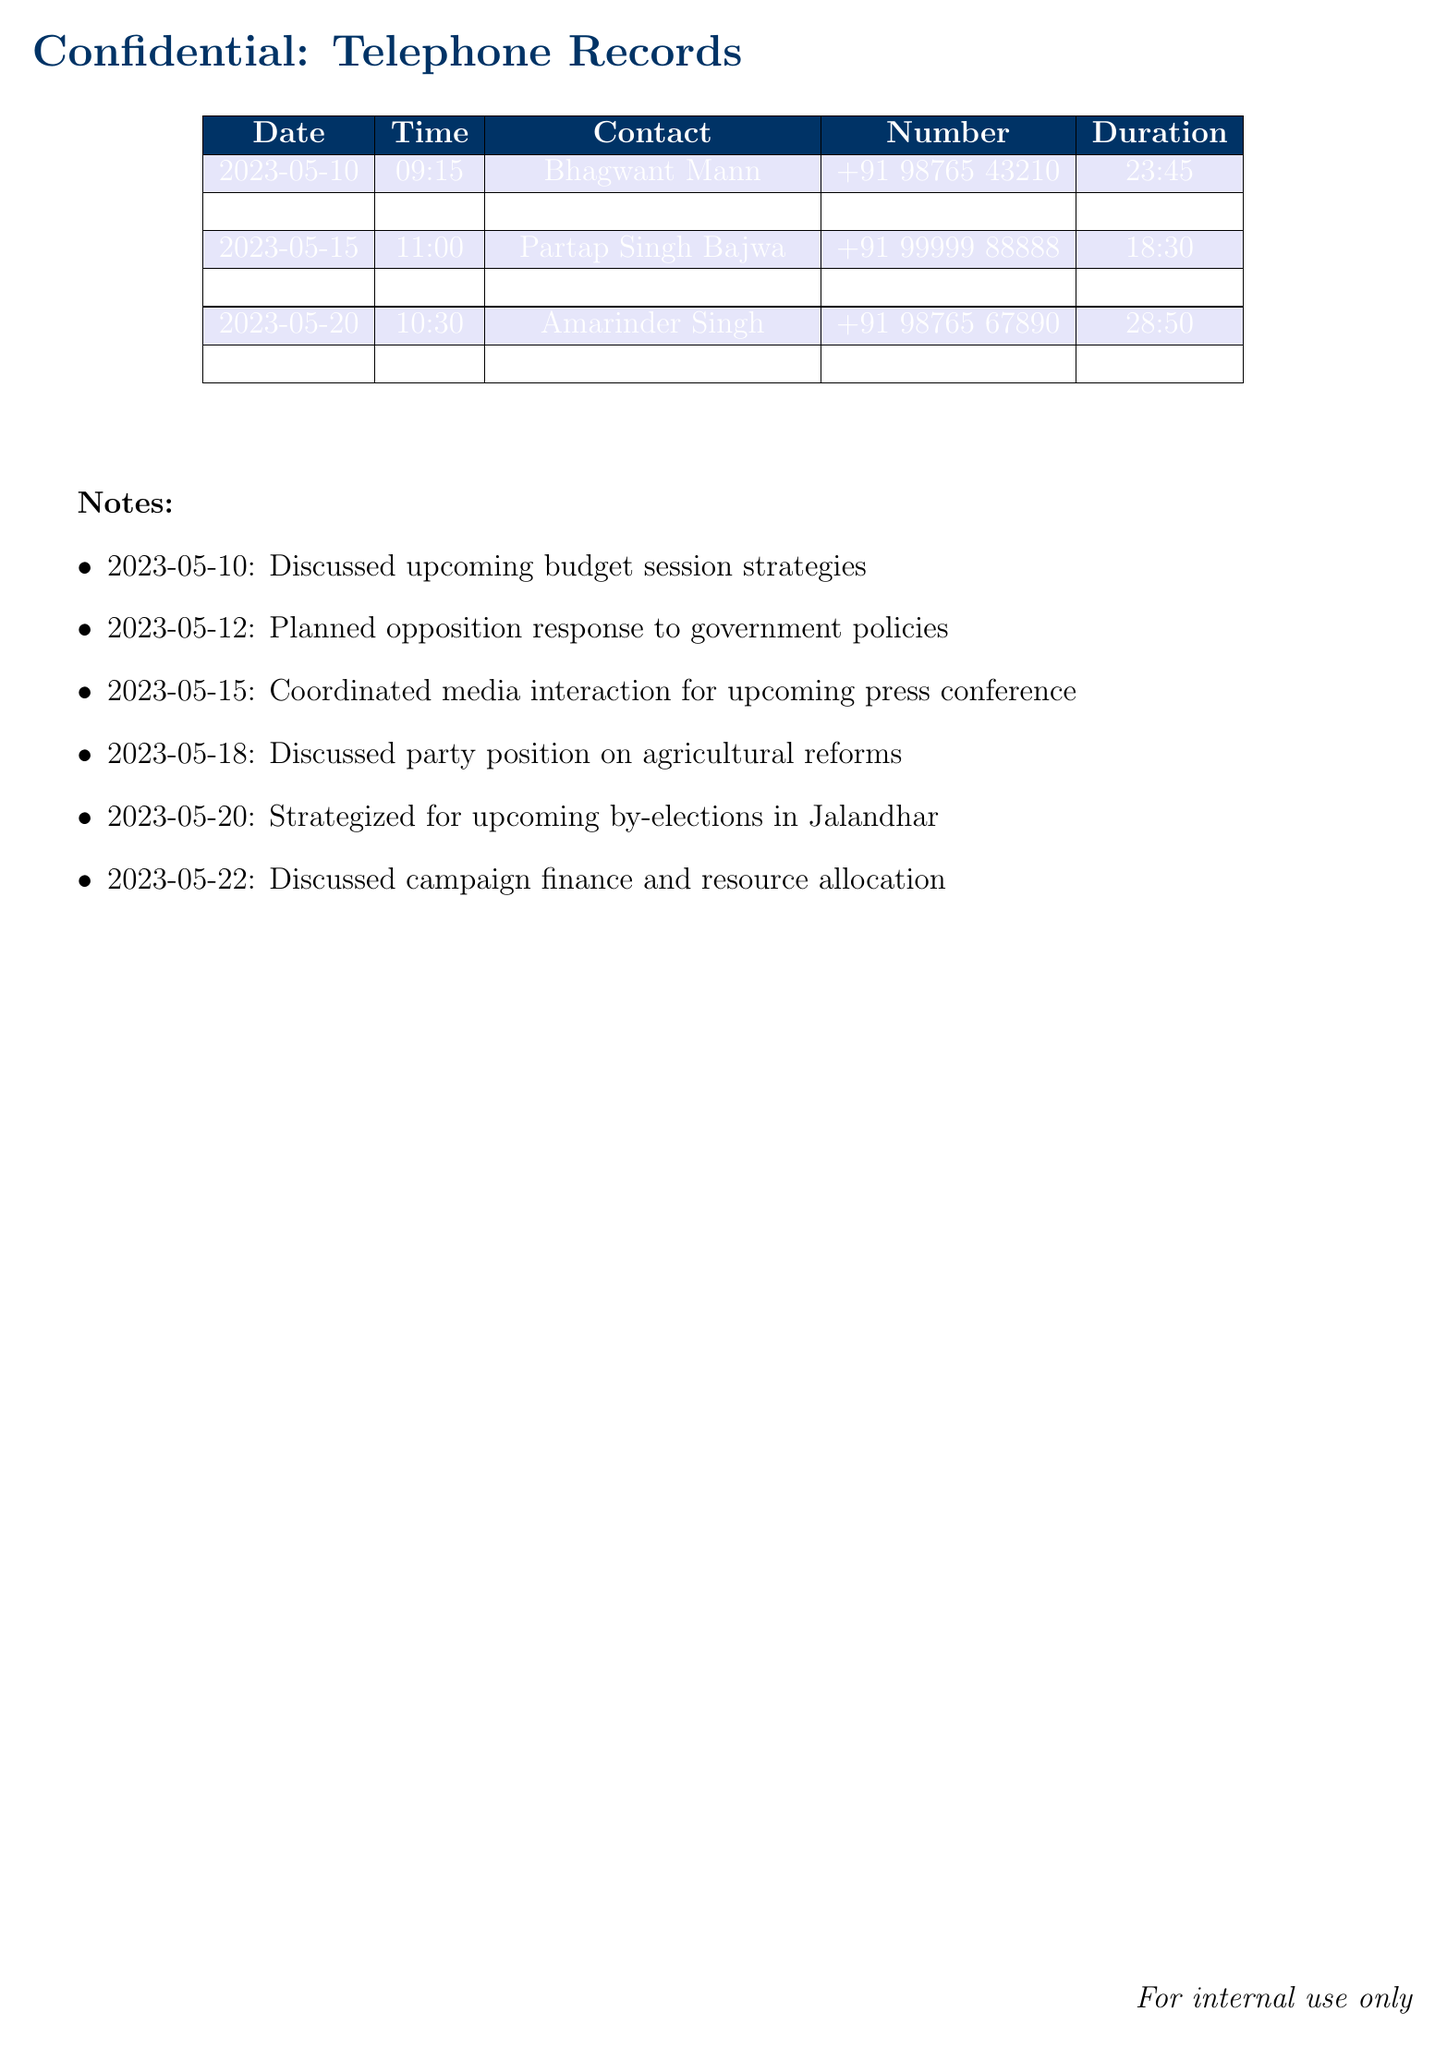What is the date of the longest call? The longest call duration is on May 12, which lasted 45 minutes and 12 seconds.
Answer: 2023-05-12 Who was the contact on May 20? The entry for May 20 indicates a conversation with Amarinder Singh.
Answer: Amarinder Singh What was the duration of the call with Navjot Singh Sidhu? The document states that the call with Navjot Singh Sidhu lasted 32 minutes and 15 seconds.
Answer: 32:15 How many calls were made in May? There are a total of 6 calls listed in May.
Answer: 6 What strategic topic was discussed on May 10? The notes indicate that the topic discussed was the upcoming budget session strategies.
Answer: Upcoming budget session strategies Which two leaders were contacted most recently? The last two contacts listed are Bikram Singh Majithia and Amarinder Singh.
Answer: Bikram Singh Majithia, Amarinder Singh 